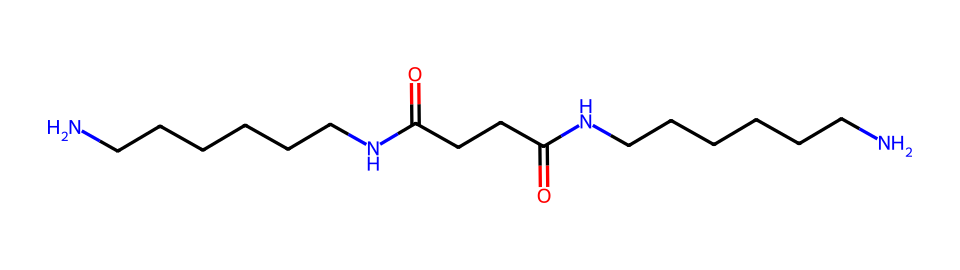what is the name of this polymer? This chemical has a structure that includes repeated amide groups (N-H bonds) associated with long hydrocarbon chains, which is characteristic of nylon. Thus, it represents a type of nylon polymer typically used in fibers.
Answer: nylon how many nitrogen atoms are present in the structure? By examining the chemical structure, we can see that there are two distinct amide linkages, which each contain one nitrogen atom. Therefore, there are a total of two nitrogen atoms in the entire structure.
Answer: 2 how many carbon atoms are found in this chemical? The structure includes a central carbon backbone and two amide groups, leading to a count of carbon atoms. Specifically, counting each carbon in the chain and the functional groups reveals there are a total of 18 carbon atoms in this chemical.
Answer: 18 what type of polymer is nylon classified as? Nylon is classified as a synthetic polymer due to its human-made nature and its method of creation through polycondensation or ring-opening polymerization of monomers. Its performance and properties allow it to be categorized specifically as a thermoplastic.
Answer: synthetic what is the main property of nylon that suits lightweight hiking gear? Nylon exhibits high tensile strength combined with lightweight properties, making it durable yet easy to carry. The combination of strength and low weight is crucial for outdoor gear, as it offers durability without adding excess weight.
Answer: high tensile strength why is the presence of amide groups significant in nylon? The amide groups in nylon contribute to its strength and elasticity due to hydrogen bonding between the chains, which enhances the overall structural integrity and resilience of the fibers. This bonding is important for maintaining the shape and durability of the hiking gear.
Answer: hydrogen bonding how does nylon compare to natural fibers in terms of water resistance? Compared to natural fibers, nylon is much more water-resistant due to its synthetic makeup, which prevents water absorption. This property provides it with an advantage in outdoor environments, where moisture resistance is necessary for gear performance.
Answer: more water-resistant 